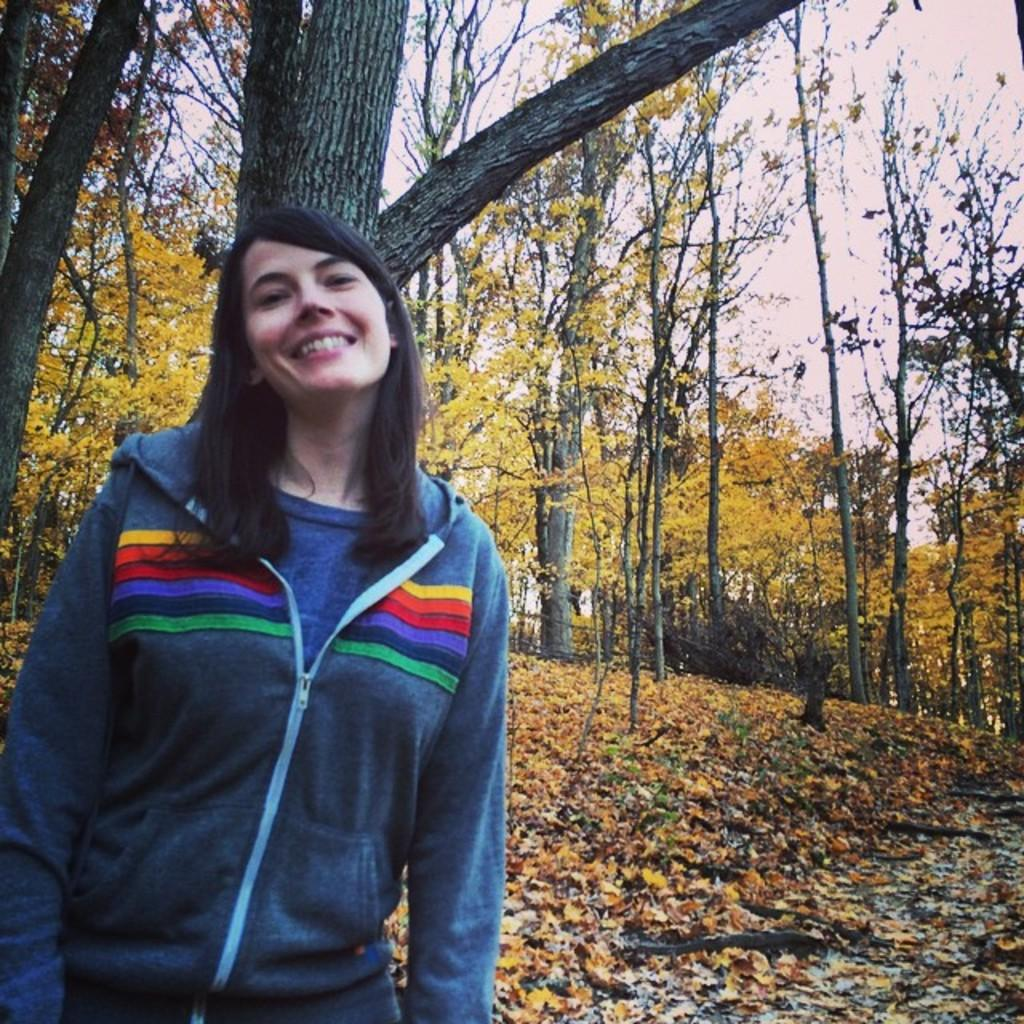What is the main subject of the image? There is a person standing in the image. What can be seen in the background of the image? Trees and the sky are visible in the background of the image. What type of vegetation is present at the bottom of the image? Leaves are present at the bottom of the image. What type of spoon is being used to stir the tub in the image? There is no spoon or tub present in the image. How does the person say good-bye to the trees in the image? The image does not depict any interaction between the person and the trees, nor does it show any form of communication. 